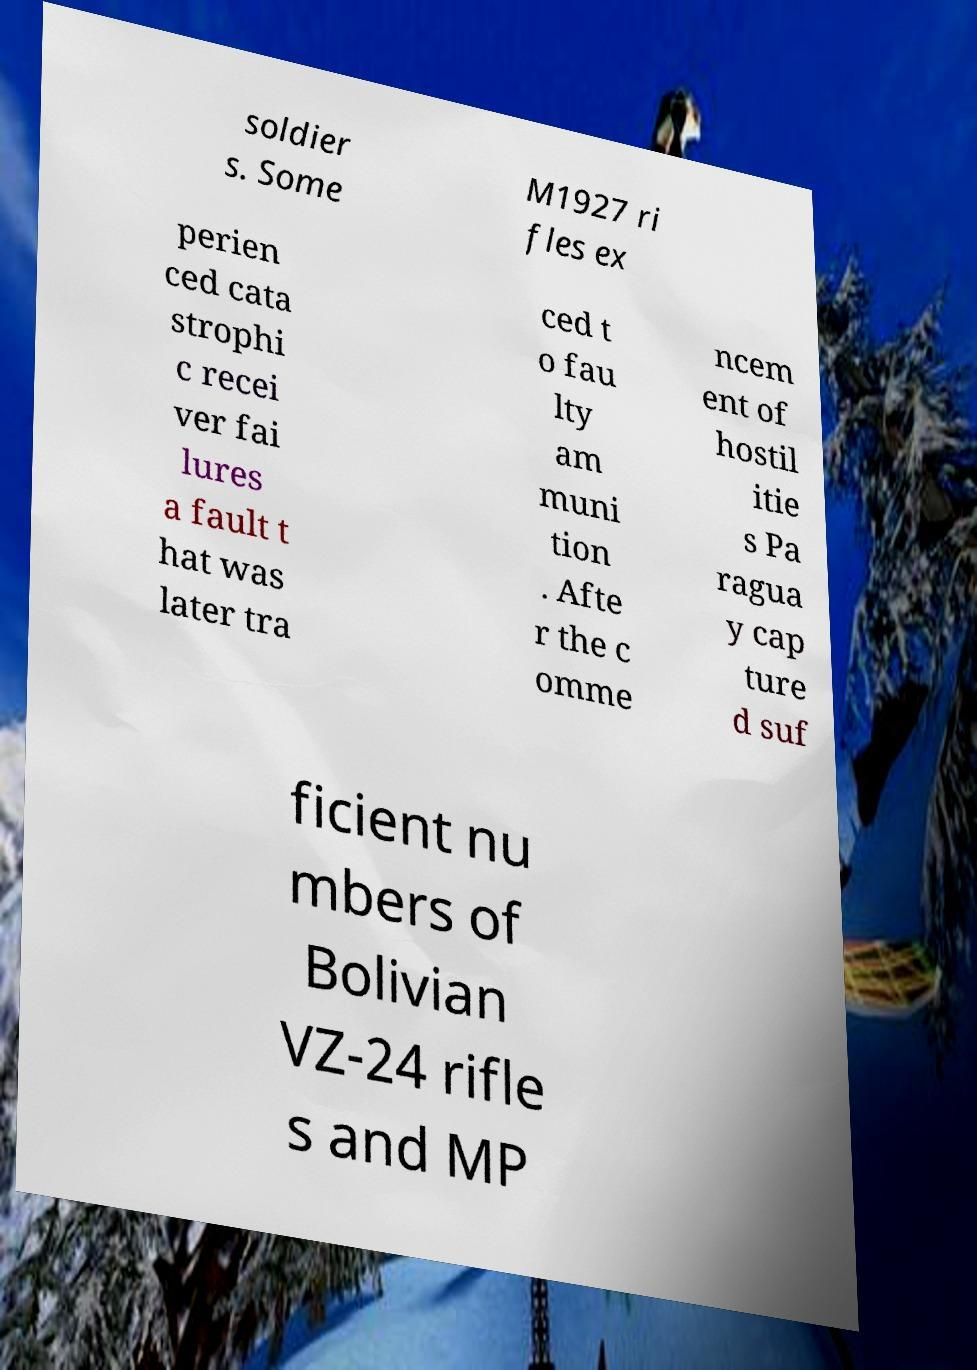There's text embedded in this image that I need extracted. Can you transcribe it verbatim? soldier s. Some M1927 ri fles ex perien ced cata strophi c recei ver fai lures a fault t hat was later tra ced t o fau lty am muni tion . Afte r the c omme ncem ent of hostil itie s Pa ragua y cap ture d suf ficient nu mbers of Bolivian VZ-24 rifle s and MP 